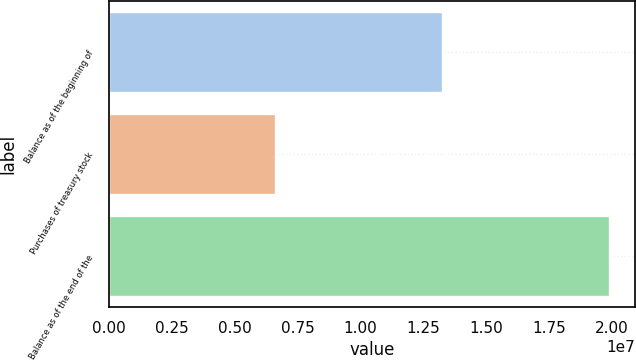Convert chart to OTSL. <chart><loc_0><loc_0><loc_500><loc_500><bar_chart><fcel>Balance as of the beginning of<fcel>Purchases of treasury stock<fcel>Balance as of the end of the<nl><fcel>1.32666e+07<fcel>6.64986e+06<fcel>1.99165e+07<nl></chart> 